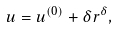Convert formula to latex. <formula><loc_0><loc_0><loc_500><loc_500>u = u ^ { ( 0 ) } + \delta r ^ { \delta } ,</formula> 